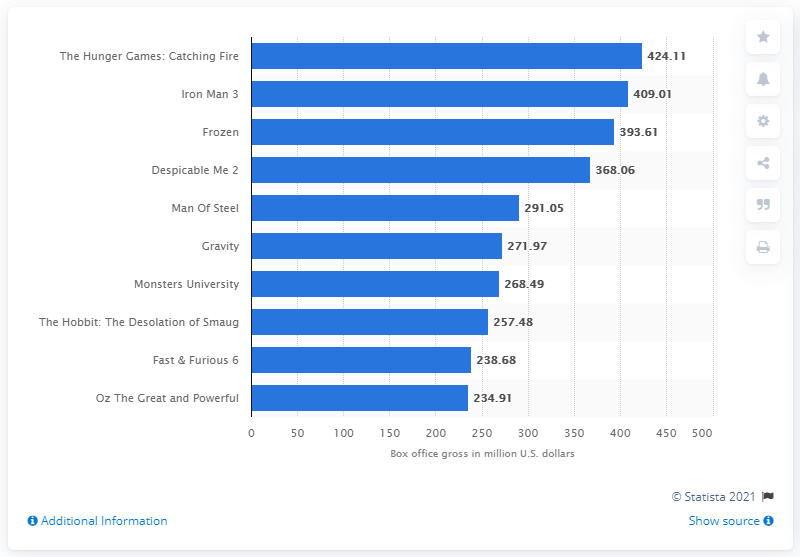Specify some key components in this picture. The box office revenue of Iron Man 3 in the US was approximately $409.01. Iron Man 3 made a total of $409.01 in US dollars. 